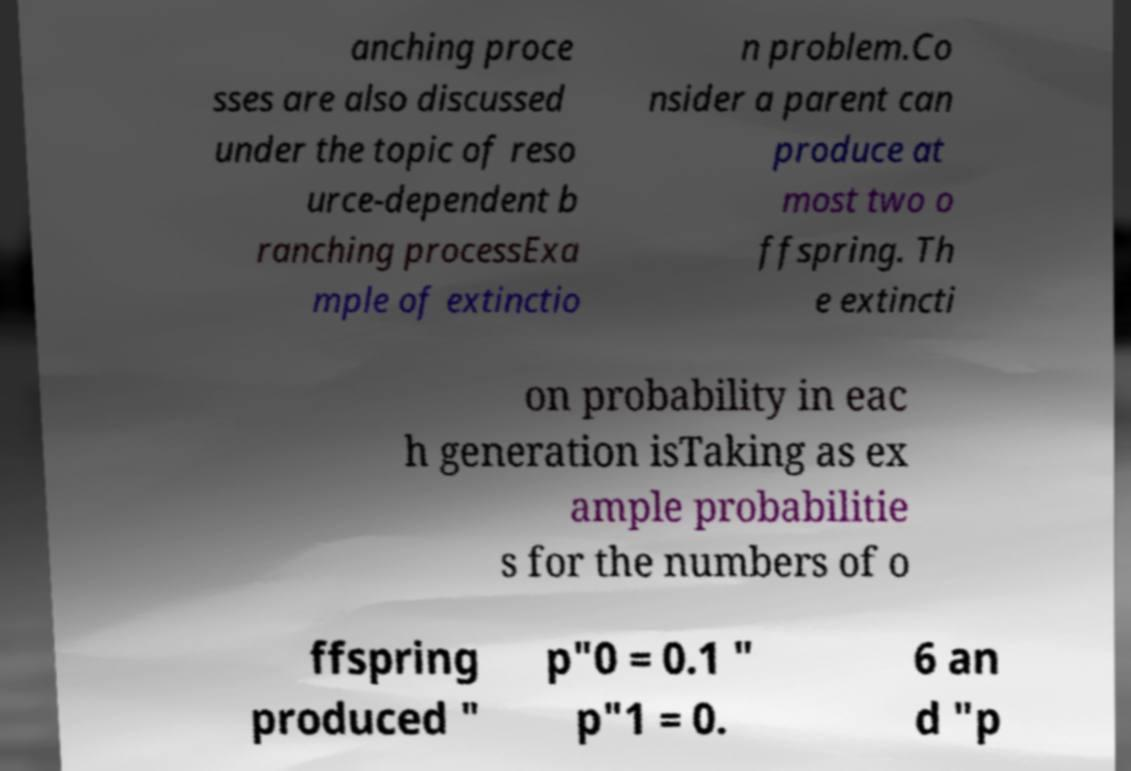Please read and relay the text visible in this image. What does it say? anching proce sses are also discussed under the topic of reso urce-dependent b ranching processExa mple of extinctio n problem.Co nsider a parent can produce at most two o ffspring. Th e extincti on probability in eac h generation isTaking as ex ample probabilitie s for the numbers of o ffspring produced " p"0 = 0.1 " p"1 = 0. 6 an d "p 